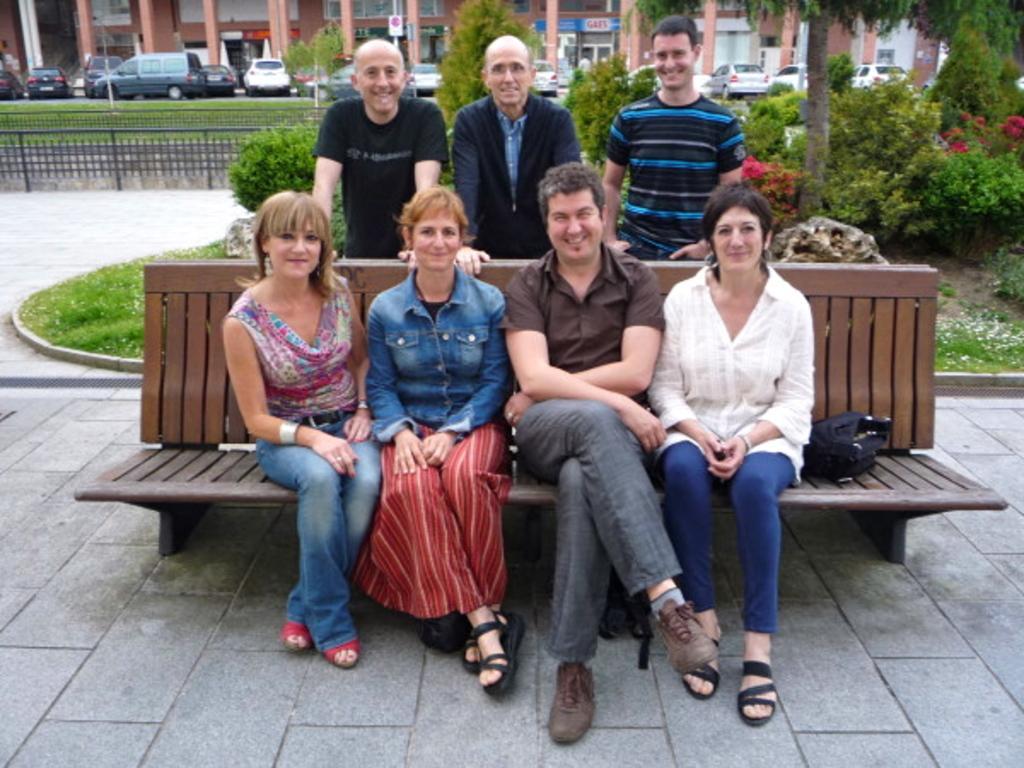Describe this image in one or two sentences. In this picture on the bench there are two ladies to the left side and one lady to the right side in the middle of them there is a man sitting. At the back of them there are three men standing, To the right side top there are some plants and trees. In the background there is a buildings with many cars. 